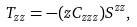Convert formula to latex. <formula><loc_0><loc_0><loc_500><loc_500>T _ { z z } = - ( z C _ { z z z } ) S ^ { z z } ,</formula> 